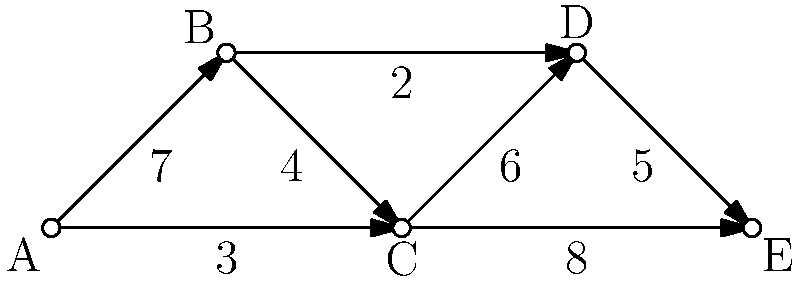As the bassist of your indie rock band, you're analyzing the popularity of different song transitions in your setlist. The weighted graph represents the flow between songs, where vertices are songs and edge weights indicate the audience's excitement level (1-10) for each transition. What is the maximum excitement path from song A to song E, and what is its total excitement score? To find the maximum excitement path from A to E, we need to consider all possible paths and their total excitement scores:

1. Path A -> B -> C -> D -> E:
   Total score = 7 + 4 + 6 + 5 = 22

2. Path A -> B -> D -> E:
   Total score = 7 + 2 + 5 = 14

3. Path A -> C -> D -> E:
   Total score = 3 + 6 + 5 = 14

4. Path A -> C -> E:
   Total score = 3 + 8 = 11

The path with the maximum excitement score is A -> B -> C -> D -> E, with a total score of 22.

To represent this path, we can use the sequence of vertices: A-B-C-D-E.
Answer: A-B-C-D-E, 22 